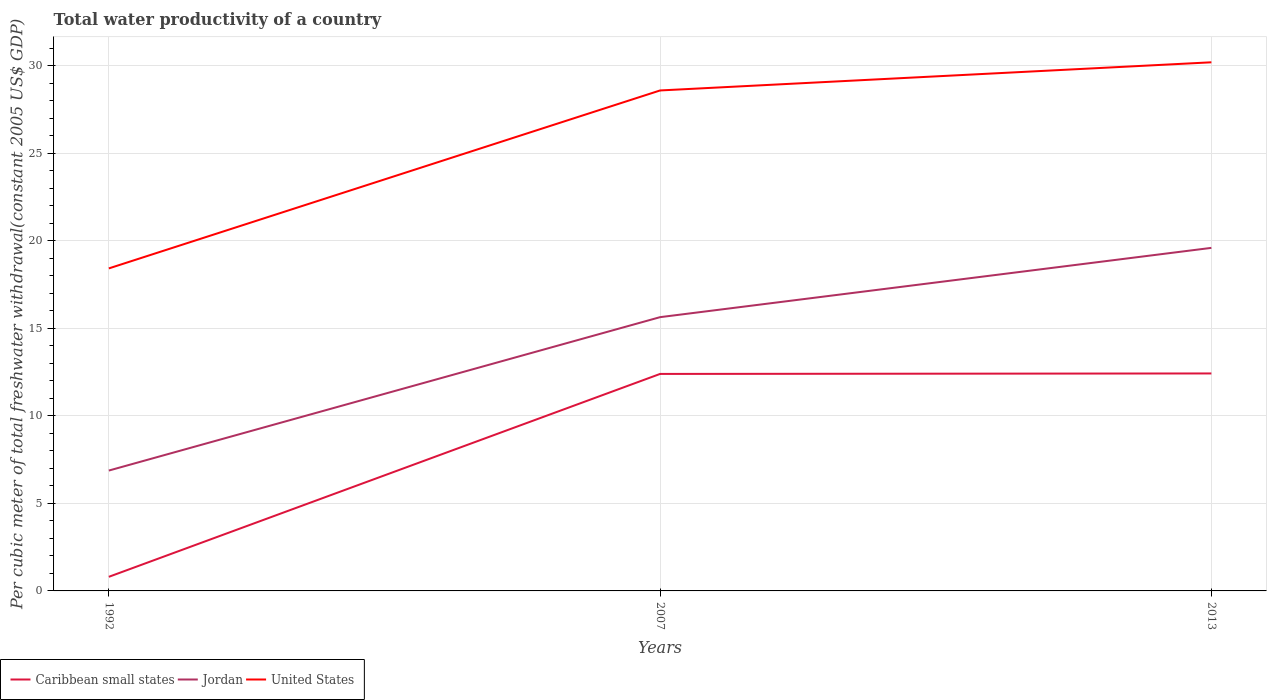How many different coloured lines are there?
Provide a succinct answer. 3. Does the line corresponding to Caribbean small states intersect with the line corresponding to United States?
Keep it short and to the point. No. Across all years, what is the maximum total water productivity in United States?
Your response must be concise. 18.43. In which year was the total water productivity in Caribbean small states maximum?
Offer a very short reply. 1992. What is the total total water productivity in Jordan in the graph?
Provide a succinct answer. -3.96. What is the difference between the highest and the second highest total water productivity in Jordan?
Your answer should be very brief. 12.73. Does the graph contain any zero values?
Your answer should be compact. No. Where does the legend appear in the graph?
Your answer should be very brief. Bottom left. What is the title of the graph?
Offer a very short reply. Total water productivity of a country. Does "Cote d'Ivoire" appear as one of the legend labels in the graph?
Offer a very short reply. No. What is the label or title of the X-axis?
Keep it short and to the point. Years. What is the label or title of the Y-axis?
Your answer should be compact. Per cubic meter of total freshwater withdrawal(constant 2005 US$ GDP). What is the Per cubic meter of total freshwater withdrawal(constant 2005 US$ GDP) of Caribbean small states in 1992?
Offer a very short reply. 0.81. What is the Per cubic meter of total freshwater withdrawal(constant 2005 US$ GDP) of Jordan in 1992?
Your answer should be very brief. 6.88. What is the Per cubic meter of total freshwater withdrawal(constant 2005 US$ GDP) of United States in 1992?
Ensure brevity in your answer.  18.43. What is the Per cubic meter of total freshwater withdrawal(constant 2005 US$ GDP) of Caribbean small states in 2007?
Offer a very short reply. 12.4. What is the Per cubic meter of total freshwater withdrawal(constant 2005 US$ GDP) of Jordan in 2007?
Your response must be concise. 15.64. What is the Per cubic meter of total freshwater withdrawal(constant 2005 US$ GDP) of United States in 2007?
Ensure brevity in your answer.  28.6. What is the Per cubic meter of total freshwater withdrawal(constant 2005 US$ GDP) of Caribbean small states in 2013?
Ensure brevity in your answer.  12.43. What is the Per cubic meter of total freshwater withdrawal(constant 2005 US$ GDP) of Jordan in 2013?
Provide a succinct answer. 19.6. What is the Per cubic meter of total freshwater withdrawal(constant 2005 US$ GDP) in United States in 2013?
Keep it short and to the point. 30.21. Across all years, what is the maximum Per cubic meter of total freshwater withdrawal(constant 2005 US$ GDP) in Caribbean small states?
Provide a succinct answer. 12.43. Across all years, what is the maximum Per cubic meter of total freshwater withdrawal(constant 2005 US$ GDP) in Jordan?
Your answer should be very brief. 19.6. Across all years, what is the maximum Per cubic meter of total freshwater withdrawal(constant 2005 US$ GDP) in United States?
Give a very brief answer. 30.21. Across all years, what is the minimum Per cubic meter of total freshwater withdrawal(constant 2005 US$ GDP) in Caribbean small states?
Offer a very short reply. 0.81. Across all years, what is the minimum Per cubic meter of total freshwater withdrawal(constant 2005 US$ GDP) in Jordan?
Your answer should be compact. 6.88. Across all years, what is the minimum Per cubic meter of total freshwater withdrawal(constant 2005 US$ GDP) in United States?
Your answer should be very brief. 18.43. What is the total Per cubic meter of total freshwater withdrawal(constant 2005 US$ GDP) of Caribbean small states in the graph?
Keep it short and to the point. 25.63. What is the total Per cubic meter of total freshwater withdrawal(constant 2005 US$ GDP) of Jordan in the graph?
Give a very brief answer. 42.13. What is the total Per cubic meter of total freshwater withdrawal(constant 2005 US$ GDP) of United States in the graph?
Give a very brief answer. 77.24. What is the difference between the Per cubic meter of total freshwater withdrawal(constant 2005 US$ GDP) in Caribbean small states in 1992 and that in 2007?
Make the answer very short. -11.59. What is the difference between the Per cubic meter of total freshwater withdrawal(constant 2005 US$ GDP) of Jordan in 1992 and that in 2007?
Offer a very short reply. -8.77. What is the difference between the Per cubic meter of total freshwater withdrawal(constant 2005 US$ GDP) in United States in 1992 and that in 2007?
Provide a succinct answer. -10.17. What is the difference between the Per cubic meter of total freshwater withdrawal(constant 2005 US$ GDP) in Caribbean small states in 1992 and that in 2013?
Your answer should be compact. -11.62. What is the difference between the Per cubic meter of total freshwater withdrawal(constant 2005 US$ GDP) in Jordan in 1992 and that in 2013?
Your answer should be very brief. -12.73. What is the difference between the Per cubic meter of total freshwater withdrawal(constant 2005 US$ GDP) of United States in 1992 and that in 2013?
Provide a succinct answer. -11.78. What is the difference between the Per cubic meter of total freshwater withdrawal(constant 2005 US$ GDP) of Caribbean small states in 2007 and that in 2013?
Give a very brief answer. -0.03. What is the difference between the Per cubic meter of total freshwater withdrawal(constant 2005 US$ GDP) in Jordan in 2007 and that in 2013?
Offer a very short reply. -3.96. What is the difference between the Per cubic meter of total freshwater withdrawal(constant 2005 US$ GDP) of United States in 2007 and that in 2013?
Ensure brevity in your answer.  -1.61. What is the difference between the Per cubic meter of total freshwater withdrawal(constant 2005 US$ GDP) in Caribbean small states in 1992 and the Per cubic meter of total freshwater withdrawal(constant 2005 US$ GDP) in Jordan in 2007?
Offer a terse response. -14.84. What is the difference between the Per cubic meter of total freshwater withdrawal(constant 2005 US$ GDP) in Caribbean small states in 1992 and the Per cubic meter of total freshwater withdrawal(constant 2005 US$ GDP) in United States in 2007?
Provide a succinct answer. -27.79. What is the difference between the Per cubic meter of total freshwater withdrawal(constant 2005 US$ GDP) of Jordan in 1992 and the Per cubic meter of total freshwater withdrawal(constant 2005 US$ GDP) of United States in 2007?
Your response must be concise. -21.72. What is the difference between the Per cubic meter of total freshwater withdrawal(constant 2005 US$ GDP) in Caribbean small states in 1992 and the Per cubic meter of total freshwater withdrawal(constant 2005 US$ GDP) in Jordan in 2013?
Keep it short and to the point. -18.8. What is the difference between the Per cubic meter of total freshwater withdrawal(constant 2005 US$ GDP) of Caribbean small states in 1992 and the Per cubic meter of total freshwater withdrawal(constant 2005 US$ GDP) of United States in 2013?
Make the answer very short. -29.4. What is the difference between the Per cubic meter of total freshwater withdrawal(constant 2005 US$ GDP) of Jordan in 1992 and the Per cubic meter of total freshwater withdrawal(constant 2005 US$ GDP) of United States in 2013?
Give a very brief answer. -23.33. What is the difference between the Per cubic meter of total freshwater withdrawal(constant 2005 US$ GDP) in Caribbean small states in 2007 and the Per cubic meter of total freshwater withdrawal(constant 2005 US$ GDP) in Jordan in 2013?
Your answer should be very brief. -7.2. What is the difference between the Per cubic meter of total freshwater withdrawal(constant 2005 US$ GDP) of Caribbean small states in 2007 and the Per cubic meter of total freshwater withdrawal(constant 2005 US$ GDP) of United States in 2013?
Provide a succinct answer. -17.81. What is the difference between the Per cubic meter of total freshwater withdrawal(constant 2005 US$ GDP) of Jordan in 2007 and the Per cubic meter of total freshwater withdrawal(constant 2005 US$ GDP) of United States in 2013?
Make the answer very short. -14.56. What is the average Per cubic meter of total freshwater withdrawal(constant 2005 US$ GDP) in Caribbean small states per year?
Keep it short and to the point. 8.54. What is the average Per cubic meter of total freshwater withdrawal(constant 2005 US$ GDP) in Jordan per year?
Keep it short and to the point. 14.04. What is the average Per cubic meter of total freshwater withdrawal(constant 2005 US$ GDP) in United States per year?
Offer a terse response. 25.75. In the year 1992, what is the difference between the Per cubic meter of total freshwater withdrawal(constant 2005 US$ GDP) of Caribbean small states and Per cubic meter of total freshwater withdrawal(constant 2005 US$ GDP) of Jordan?
Your response must be concise. -6.07. In the year 1992, what is the difference between the Per cubic meter of total freshwater withdrawal(constant 2005 US$ GDP) in Caribbean small states and Per cubic meter of total freshwater withdrawal(constant 2005 US$ GDP) in United States?
Provide a short and direct response. -17.62. In the year 1992, what is the difference between the Per cubic meter of total freshwater withdrawal(constant 2005 US$ GDP) in Jordan and Per cubic meter of total freshwater withdrawal(constant 2005 US$ GDP) in United States?
Your answer should be compact. -11.55. In the year 2007, what is the difference between the Per cubic meter of total freshwater withdrawal(constant 2005 US$ GDP) of Caribbean small states and Per cubic meter of total freshwater withdrawal(constant 2005 US$ GDP) of Jordan?
Your answer should be very brief. -3.24. In the year 2007, what is the difference between the Per cubic meter of total freshwater withdrawal(constant 2005 US$ GDP) of Caribbean small states and Per cubic meter of total freshwater withdrawal(constant 2005 US$ GDP) of United States?
Offer a very short reply. -16.2. In the year 2007, what is the difference between the Per cubic meter of total freshwater withdrawal(constant 2005 US$ GDP) of Jordan and Per cubic meter of total freshwater withdrawal(constant 2005 US$ GDP) of United States?
Your response must be concise. -12.95. In the year 2013, what is the difference between the Per cubic meter of total freshwater withdrawal(constant 2005 US$ GDP) in Caribbean small states and Per cubic meter of total freshwater withdrawal(constant 2005 US$ GDP) in Jordan?
Ensure brevity in your answer.  -7.18. In the year 2013, what is the difference between the Per cubic meter of total freshwater withdrawal(constant 2005 US$ GDP) in Caribbean small states and Per cubic meter of total freshwater withdrawal(constant 2005 US$ GDP) in United States?
Provide a short and direct response. -17.78. In the year 2013, what is the difference between the Per cubic meter of total freshwater withdrawal(constant 2005 US$ GDP) in Jordan and Per cubic meter of total freshwater withdrawal(constant 2005 US$ GDP) in United States?
Provide a short and direct response. -10.6. What is the ratio of the Per cubic meter of total freshwater withdrawal(constant 2005 US$ GDP) of Caribbean small states in 1992 to that in 2007?
Provide a succinct answer. 0.07. What is the ratio of the Per cubic meter of total freshwater withdrawal(constant 2005 US$ GDP) of Jordan in 1992 to that in 2007?
Make the answer very short. 0.44. What is the ratio of the Per cubic meter of total freshwater withdrawal(constant 2005 US$ GDP) in United States in 1992 to that in 2007?
Ensure brevity in your answer.  0.64. What is the ratio of the Per cubic meter of total freshwater withdrawal(constant 2005 US$ GDP) in Caribbean small states in 1992 to that in 2013?
Make the answer very short. 0.06. What is the ratio of the Per cubic meter of total freshwater withdrawal(constant 2005 US$ GDP) of Jordan in 1992 to that in 2013?
Make the answer very short. 0.35. What is the ratio of the Per cubic meter of total freshwater withdrawal(constant 2005 US$ GDP) of United States in 1992 to that in 2013?
Offer a very short reply. 0.61. What is the ratio of the Per cubic meter of total freshwater withdrawal(constant 2005 US$ GDP) of Jordan in 2007 to that in 2013?
Offer a very short reply. 0.8. What is the ratio of the Per cubic meter of total freshwater withdrawal(constant 2005 US$ GDP) of United States in 2007 to that in 2013?
Make the answer very short. 0.95. What is the difference between the highest and the second highest Per cubic meter of total freshwater withdrawal(constant 2005 US$ GDP) of Caribbean small states?
Ensure brevity in your answer.  0.03. What is the difference between the highest and the second highest Per cubic meter of total freshwater withdrawal(constant 2005 US$ GDP) of Jordan?
Keep it short and to the point. 3.96. What is the difference between the highest and the second highest Per cubic meter of total freshwater withdrawal(constant 2005 US$ GDP) in United States?
Offer a terse response. 1.61. What is the difference between the highest and the lowest Per cubic meter of total freshwater withdrawal(constant 2005 US$ GDP) of Caribbean small states?
Give a very brief answer. 11.62. What is the difference between the highest and the lowest Per cubic meter of total freshwater withdrawal(constant 2005 US$ GDP) in Jordan?
Offer a terse response. 12.73. What is the difference between the highest and the lowest Per cubic meter of total freshwater withdrawal(constant 2005 US$ GDP) in United States?
Your answer should be compact. 11.78. 